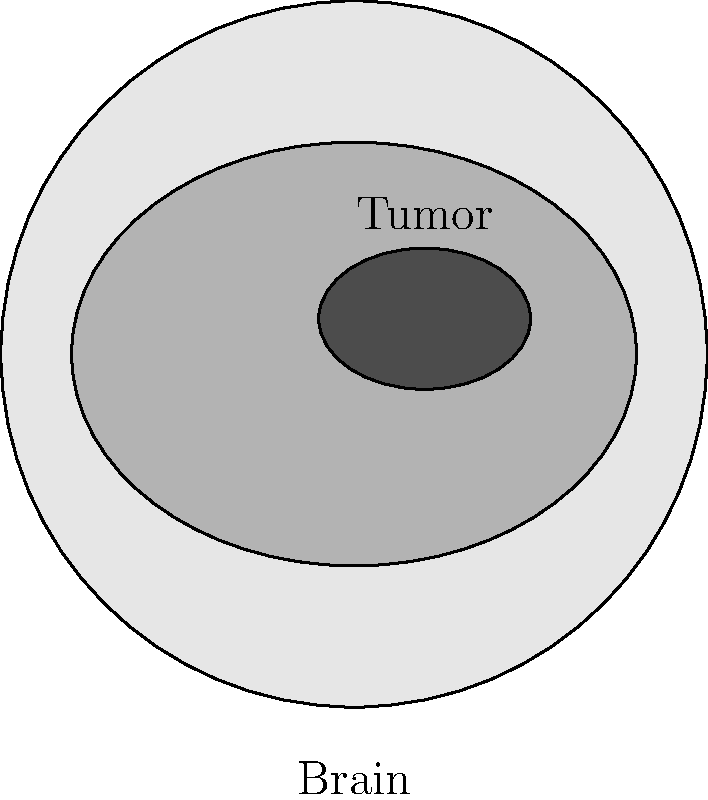In the context of implementing machine learning for medical imaging analysis, consider the sample MRI image provided. Which of the following machine learning techniques would be most appropriate for automatically detecting and segmenting the tumor in this brain scan?

A) Convolutional Neural Networks (CNNs)
B) Linear Regression
C) Decision Trees
D) K-Means Clustering To determine the most appropriate machine learning technique for automatically detecting and segmenting the tumor in the given brain MRI scan, let's consider each option:

1. Convolutional Neural Networks (CNNs):
   - CNNs are specialized deep learning models designed for processing grid-like data, such as images.
   - They use convolutional layers to automatically learn hierarchical features from images.
   - CNNs excel at tasks like image classification, object detection, and semantic segmentation.
   - They can learn to identify complex patterns and structures in medical images.

2. Linear Regression:
   - Linear regression is used for predicting continuous values based on linear relationships between variables.
   - It's not suitable for image analysis or complex pattern recognition tasks.

3. Decision Trees:
   - Decision trees are used for classification and regression tasks based on a series of decisions.
   - While they can be used for some image analysis tasks, they're not as effective as CNNs for complex image segmentation.

4. K-Means Clustering:
   - K-Means is an unsupervised learning algorithm used for grouping similar data points.
   - While it can be used for simple image segmentation, it's not as powerful or accurate as CNNs for complex medical image analysis.

Given the complexity of tumor detection and segmentation in MRI scans, Convolutional Neural Networks (CNNs) are the most appropriate choice. CNNs can:

1. Learn to identify features specific to tumors in brain scans.
2. Perform pixel-level segmentation to accurately outline the tumor.
3. Handle variations in tumor size, shape, and location across different scans.
4. Achieve high accuracy in tumor detection and segmentation tasks.

Therefore, the most appropriate machine learning technique for this task is Convolutional Neural Networks (CNNs).
Answer: Convolutional Neural Networks (CNNs) 